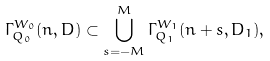<formula> <loc_0><loc_0><loc_500><loc_500>\Gamma _ { Q _ { 0 } } ^ { W _ { 0 } } ( n , D ) \subset \bigcup _ { s = - M } ^ { M } \Gamma _ { Q _ { 1 } } ^ { W _ { 1 } } ( n + s , D _ { 1 } ) ,</formula> 